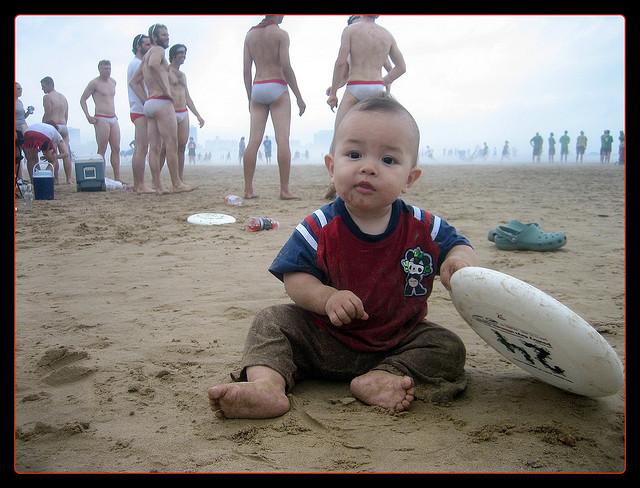Does the baby want to play?
Quick response, please. Yes. Is there a baby pictured?
Give a very brief answer. Yes. Are all the men in the background wearing the same swimming underwear?
Give a very brief answer. Yes. What is sticking up from the sand?
Answer briefly. Frisbee. Is the baby eating?
Keep it brief. No. 